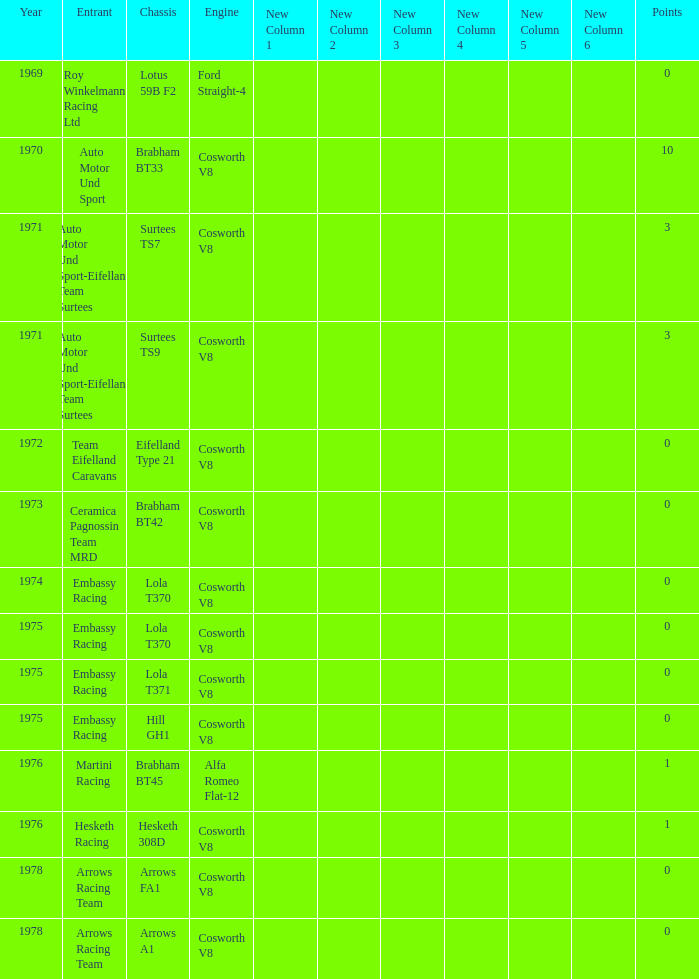In 1970, what entrant had a cosworth v8 engine? Auto Motor Und Sport. 